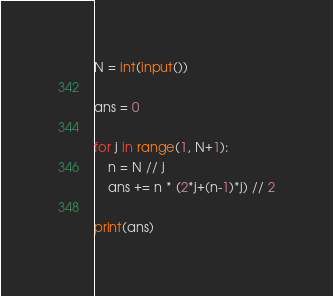Convert code to text. <code><loc_0><loc_0><loc_500><loc_500><_Python_>N = int(input())

ans = 0

for j in range(1, N+1):
    n = N // j
    ans += n * (2*j+(n-1)*j) // 2

print(ans)

</code> 